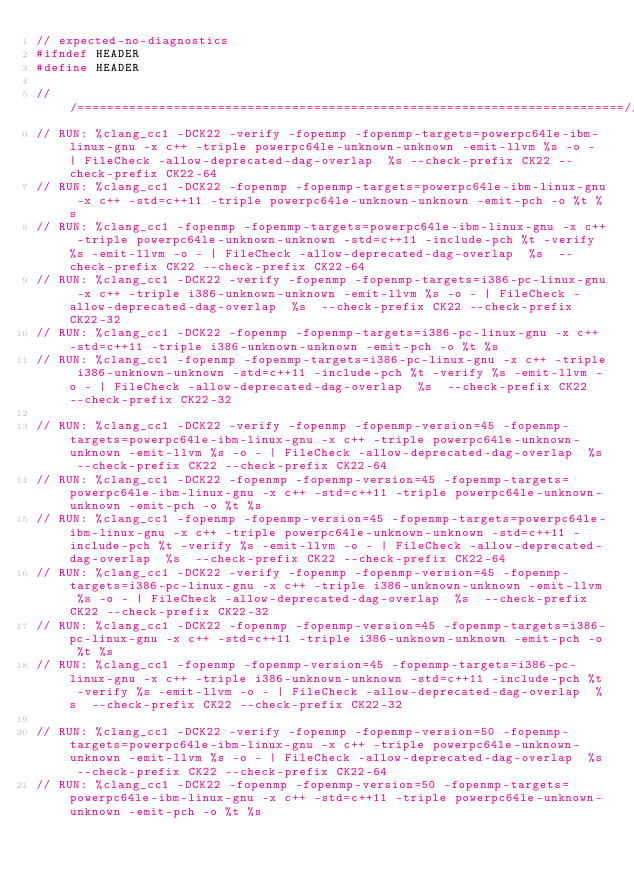<code> <loc_0><loc_0><loc_500><loc_500><_C++_>// expected-no-diagnostics
#ifndef HEADER
#define HEADER

///==========================================================================///
// RUN: %clang_cc1 -DCK22 -verify -fopenmp -fopenmp-targets=powerpc64le-ibm-linux-gnu -x c++ -triple powerpc64le-unknown-unknown -emit-llvm %s -o - | FileCheck -allow-deprecated-dag-overlap  %s --check-prefix CK22 --check-prefix CK22-64
// RUN: %clang_cc1 -DCK22 -fopenmp -fopenmp-targets=powerpc64le-ibm-linux-gnu -x c++ -std=c++11 -triple powerpc64le-unknown-unknown -emit-pch -o %t %s
// RUN: %clang_cc1 -fopenmp -fopenmp-targets=powerpc64le-ibm-linux-gnu -x c++ -triple powerpc64le-unknown-unknown -std=c++11 -include-pch %t -verify %s -emit-llvm -o - | FileCheck -allow-deprecated-dag-overlap  %s  --check-prefix CK22 --check-prefix CK22-64
// RUN: %clang_cc1 -DCK22 -verify -fopenmp -fopenmp-targets=i386-pc-linux-gnu -x c++ -triple i386-unknown-unknown -emit-llvm %s -o - | FileCheck -allow-deprecated-dag-overlap  %s  --check-prefix CK22 --check-prefix CK22-32
// RUN: %clang_cc1 -DCK22 -fopenmp -fopenmp-targets=i386-pc-linux-gnu -x c++ -std=c++11 -triple i386-unknown-unknown -emit-pch -o %t %s
// RUN: %clang_cc1 -fopenmp -fopenmp-targets=i386-pc-linux-gnu -x c++ -triple i386-unknown-unknown -std=c++11 -include-pch %t -verify %s -emit-llvm -o - | FileCheck -allow-deprecated-dag-overlap  %s  --check-prefix CK22 --check-prefix CK22-32

// RUN: %clang_cc1 -DCK22 -verify -fopenmp -fopenmp-version=45 -fopenmp-targets=powerpc64le-ibm-linux-gnu -x c++ -triple powerpc64le-unknown-unknown -emit-llvm %s -o - | FileCheck -allow-deprecated-dag-overlap  %s --check-prefix CK22 --check-prefix CK22-64
// RUN: %clang_cc1 -DCK22 -fopenmp -fopenmp-version=45 -fopenmp-targets=powerpc64le-ibm-linux-gnu -x c++ -std=c++11 -triple powerpc64le-unknown-unknown -emit-pch -o %t %s
// RUN: %clang_cc1 -fopenmp -fopenmp-version=45 -fopenmp-targets=powerpc64le-ibm-linux-gnu -x c++ -triple powerpc64le-unknown-unknown -std=c++11 -include-pch %t -verify %s -emit-llvm -o - | FileCheck -allow-deprecated-dag-overlap  %s  --check-prefix CK22 --check-prefix CK22-64
// RUN: %clang_cc1 -DCK22 -verify -fopenmp -fopenmp-version=45 -fopenmp-targets=i386-pc-linux-gnu -x c++ -triple i386-unknown-unknown -emit-llvm %s -o - | FileCheck -allow-deprecated-dag-overlap  %s  --check-prefix CK22 --check-prefix CK22-32
// RUN: %clang_cc1 -DCK22 -fopenmp -fopenmp-version=45 -fopenmp-targets=i386-pc-linux-gnu -x c++ -std=c++11 -triple i386-unknown-unknown -emit-pch -o %t %s
// RUN: %clang_cc1 -fopenmp -fopenmp-version=45 -fopenmp-targets=i386-pc-linux-gnu -x c++ -triple i386-unknown-unknown -std=c++11 -include-pch %t -verify %s -emit-llvm -o - | FileCheck -allow-deprecated-dag-overlap  %s  --check-prefix CK22 --check-prefix CK22-32

// RUN: %clang_cc1 -DCK22 -verify -fopenmp -fopenmp-version=50 -fopenmp-targets=powerpc64le-ibm-linux-gnu -x c++ -triple powerpc64le-unknown-unknown -emit-llvm %s -o - | FileCheck -allow-deprecated-dag-overlap  %s --check-prefix CK22 --check-prefix CK22-64
// RUN: %clang_cc1 -DCK22 -fopenmp -fopenmp-version=50 -fopenmp-targets=powerpc64le-ibm-linux-gnu -x c++ -std=c++11 -triple powerpc64le-unknown-unknown -emit-pch -o %t %s</code> 